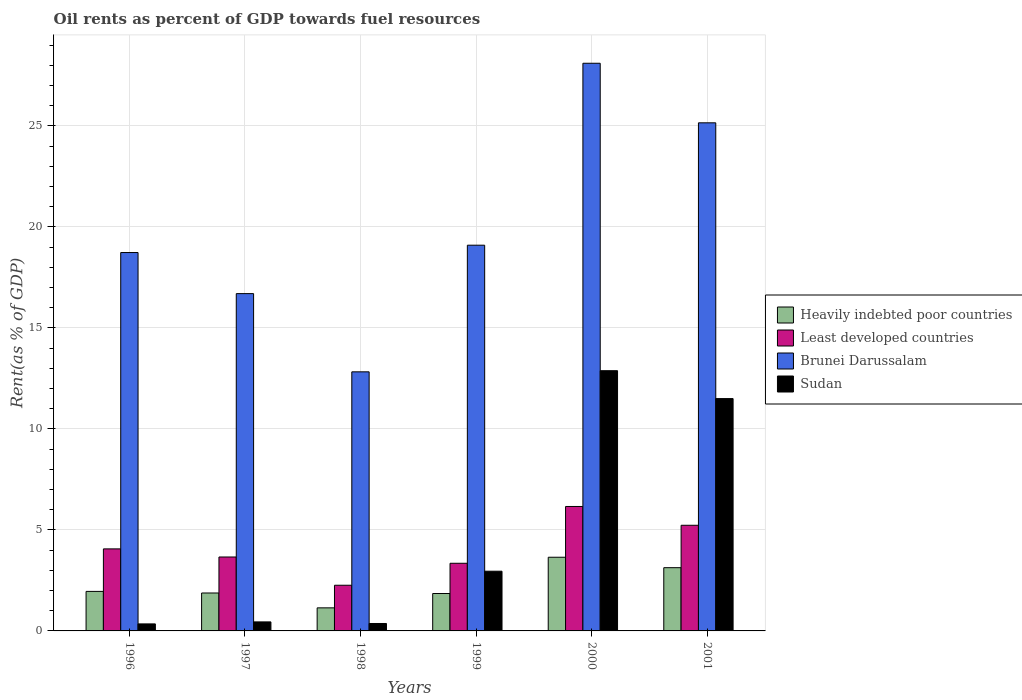How many different coloured bars are there?
Your answer should be very brief. 4. Are the number of bars on each tick of the X-axis equal?
Your response must be concise. Yes. How many bars are there on the 2nd tick from the right?
Make the answer very short. 4. What is the oil rent in Sudan in 1999?
Give a very brief answer. 2.96. Across all years, what is the maximum oil rent in Least developed countries?
Provide a short and direct response. 6.16. Across all years, what is the minimum oil rent in Least developed countries?
Offer a terse response. 2.26. In which year was the oil rent in Heavily indebted poor countries maximum?
Provide a succinct answer. 2000. In which year was the oil rent in Sudan minimum?
Provide a short and direct response. 1996. What is the total oil rent in Sudan in the graph?
Ensure brevity in your answer.  28.5. What is the difference between the oil rent in Least developed countries in 1998 and that in 2000?
Make the answer very short. -3.9. What is the difference between the oil rent in Brunei Darussalam in 2000 and the oil rent in Sudan in 1996?
Provide a succinct answer. 27.76. What is the average oil rent in Heavily indebted poor countries per year?
Give a very brief answer. 2.27. In the year 2001, what is the difference between the oil rent in Brunei Darussalam and oil rent in Heavily indebted poor countries?
Keep it short and to the point. 22.02. What is the ratio of the oil rent in Sudan in 1996 to that in 1998?
Make the answer very short. 0.94. Is the oil rent in Brunei Darussalam in 1998 less than that in 1999?
Provide a short and direct response. Yes. Is the difference between the oil rent in Brunei Darussalam in 1997 and 2000 greater than the difference between the oil rent in Heavily indebted poor countries in 1997 and 2000?
Your response must be concise. No. What is the difference between the highest and the second highest oil rent in Sudan?
Offer a terse response. 1.38. What is the difference between the highest and the lowest oil rent in Heavily indebted poor countries?
Your answer should be compact. 2.51. In how many years, is the oil rent in Heavily indebted poor countries greater than the average oil rent in Heavily indebted poor countries taken over all years?
Keep it short and to the point. 2. Is the sum of the oil rent in Brunei Darussalam in 1998 and 1999 greater than the maximum oil rent in Heavily indebted poor countries across all years?
Your response must be concise. Yes. Is it the case that in every year, the sum of the oil rent in Brunei Darussalam and oil rent in Least developed countries is greater than the sum of oil rent in Sudan and oil rent in Heavily indebted poor countries?
Your answer should be compact. Yes. What does the 3rd bar from the left in 2001 represents?
Ensure brevity in your answer.  Brunei Darussalam. What does the 2nd bar from the right in 2001 represents?
Ensure brevity in your answer.  Brunei Darussalam. Is it the case that in every year, the sum of the oil rent in Heavily indebted poor countries and oil rent in Sudan is greater than the oil rent in Brunei Darussalam?
Your answer should be compact. No. How many years are there in the graph?
Ensure brevity in your answer.  6. What is the difference between two consecutive major ticks on the Y-axis?
Provide a succinct answer. 5. Are the values on the major ticks of Y-axis written in scientific E-notation?
Your answer should be very brief. No. How many legend labels are there?
Your answer should be compact. 4. What is the title of the graph?
Provide a succinct answer. Oil rents as percent of GDP towards fuel resources. What is the label or title of the X-axis?
Your response must be concise. Years. What is the label or title of the Y-axis?
Ensure brevity in your answer.  Rent(as % of GDP). What is the Rent(as % of GDP) of Heavily indebted poor countries in 1996?
Offer a terse response. 1.96. What is the Rent(as % of GDP) of Least developed countries in 1996?
Provide a short and direct response. 4.06. What is the Rent(as % of GDP) in Brunei Darussalam in 1996?
Make the answer very short. 18.73. What is the Rent(as % of GDP) in Sudan in 1996?
Offer a terse response. 0.35. What is the Rent(as % of GDP) in Heavily indebted poor countries in 1997?
Your answer should be compact. 1.88. What is the Rent(as % of GDP) in Least developed countries in 1997?
Make the answer very short. 3.66. What is the Rent(as % of GDP) of Brunei Darussalam in 1997?
Provide a short and direct response. 16.7. What is the Rent(as % of GDP) of Sudan in 1997?
Keep it short and to the point. 0.45. What is the Rent(as % of GDP) of Heavily indebted poor countries in 1998?
Offer a very short reply. 1.14. What is the Rent(as % of GDP) in Least developed countries in 1998?
Your answer should be very brief. 2.26. What is the Rent(as % of GDP) in Brunei Darussalam in 1998?
Keep it short and to the point. 12.83. What is the Rent(as % of GDP) in Sudan in 1998?
Give a very brief answer. 0.37. What is the Rent(as % of GDP) in Heavily indebted poor countries in 1999?
Offer a terse response. 1.85. What is the Rent(as % of GDP) of Least developed countries in 1999?
Offer a very short reply. 3.35. What is the Rent(as % of GDP) in Brunei Darussalam in 1999?
Your response must be concise. 19.1. What is the Rent(as % of GDP) in Sudan in 1999?
Provide a short and direct response. 2.96. What is the Rent(as % of GDP) in Heavily indebted poor countries in 2000?
Ensure brevity in your answer.  3.65. What is the Rent(as % of GDP) in Least developed countries in 2000?
Make the answer very short. 6.16. What is the Rent(as % of GDP) in Brunei Darussalam in 2000?
Your response must be concise. 28.1. What is the Rent(as % of GDP) in Sudan in 2000?
Provide a succinct answer. 12.88. What is the Rent(as % of GDP) of Heavily indebted poor countries in 2001?
Your answer should be compact. 3.13. What is the Rent(as % of GDP) of Least developed countries in 2001?
Give a very brief answer. 5.23. What is the Rent(as % of GDP) in Brunei Darussalam in 2001?
Your answer should be compact. 25.15. What is the Rent(as % of GDP) in Sudan in 2001?
Your answer should be compact. 11.5. Across all years, what is the maximum Rent(as % of GDP) of Heavily indebted poor countries?
Provide a succinct answer. 3.65. Across all years, what is the maximum Rent(as % of GDP) of Least developed countries?
Your answer should be compact. 6.16. Across all years, what is the maximum Rent(as % of GDP) in Brunei Darussalam?
Ensure brevity in your answer.  28.1. Across all years, what is the maximum Rent(as % of GDP) in Sudan?
Provide a succinct answer. 12.88. Across all years, what is the minimum Rent(as % of GDP) in Heavily indebted poor countries?
Offer a terse response. 1.14. Across all years, what is the minimum Rent(as % of GDP) in Least developed countries?
Ensure brevity in your answer.  2.26. Across all years, what is the minimum Rent(as % of GDP) of Brunei Darussalam?
Your answer should be compact. 12.83. Across all years, what is the minimum Rent(as % of GDP) in Sudan?
Provide a short and direct response. 0.35. What is the total Rent(as % of GDP) of Heavily indebted poor countries in the graph?
Give a very brief answer. 13.61. What is the total Rent(as % of GDP) in Least developed countries in the graph?
Your answer should be very brief. 24.72. What is the total Rent(as % of GDP) of Brunei Darussalam in the graph?
Provide a short and direct response. 120.61. What is the total Rent(as % of GDP) in Sudan in the graph?
Your answer should be compact. 28.5. What is the difference between the Rent(as % of GDP) of Heavily indebted poor countries in 1996 and that in 1997?
Your answer should be compact. 0.08. What is the difference between the Rent(as % of GDP) in Least developed countries in 1996 and that in 1997?
Provide a short and direct response. 0.4. What is the difference between the Rent(as % of GDP) of Brunei Darussalam in 1996 and that in 1997?
Your answer should be compact. 2.03. What is the difference between the Rent(as % of GDP) in Sudan in 1996 and that in 1997?
Ensure brevity in your answer.  -0.1. What is the difference between the Rent(as % of GDP) of Heavily indebted poor countries in 1996 and that in 1998?
Your response must be concise. 0.81. What is the difference between the Rent(as % of GDP) of Least developed countries in 1996 and that in 1998?
Your answer should be very brief. 1.8. What is the difference between the Rent(as % of GDP) of Brunei Darussalam in 1996 and that in 1998?
Offer a terse response. 5.91. What is the difference between the Rent(as % of GDP) in Sudan in 1996 and that in 1998?
Your response must be concise. -0.02. What is the difference between the Rent(as % of GDP) in Heavily indebted poor countries in 1996 and that in 1999?
Provide a short and direct response. 0.1. What is the difference between the Rent(as % of GDP) in Least developed countries in 1996 and that in 1999?
Offer a terse response. 0.71. What is the difference between the Rent(as % of GDP) of Brunei Darussalam in 1996 and that in 1999?
Your answer should be very brief. -0.36. What is the difference between the Rent(as % of GDP) of Sudan in 1996 and that in 1999?
Your answer should be very brief. -2.61. What is the difference between the Rent(as % of GDP) of Heavily indebted poor countries in 1996 and that in 2000?
Your response must be concise. -1.69. What is the difference between the Rent(as % of GDP) in Least developed countries in 1996 and that in 2000?
Your answer should be compact. -2.1. What is the difference between the Rent(as % of GDP) in Brunei Darussalam in 1996 and that in 2000?
Your response must be concise. -9.37. What is the difference between the Rent(as % of GDP) of Sudan in 1996 and that in 2000?
Your response must be concise. -12.54. What is the difference between the Rent(as % of GDP) of Heavily indebted poor countries in 1996 and that in 2001?
Provide a succinct answer. -1.17. What is the difference between the Rent(as % of GDP) of Least developed countries in 1996 and that in 2001?
Ensure brevity in your answer.  -1.17. What is the difference between the Rent(as % of GDP) of Brunei Darussalam in 1996 and that in 2001?
Keep it short and to the point. -6.42. What is the difference between the Rent(as % of GDP) of Sudan in 1996 and that in 2001?
Provide a succinct answer. -11.15. What is the difference between the Rent(as % of GDP) of Heavily indebted poor countries in 1997 and that in 1998?
Give a very brief answer. 0.74. What is the difference between the Rent(as % of GDP) of Least developed countries in 1997 and that in 1998?
Your answer should be compact. 1.4. What is the difference between the Rent(as % of GDP) in Brunei Darussalam in 1997 and that in 1998?
Offer a very short reply. 3.87. What is the difference between the Rent(as % of GDP) of Sudan in 1997 and that in 1998?
Offer a terse response. 0.08. What is the difference between the Rent(as % of GDP) in Heavily indebted poor countries in 1997 and that in 1999?
Provide a short and direct response. 0.03. What is the difference between the Rent(as % of GDP) in Least developed countries in 1997 and that in 1999?
Ensure brevity in your answer.  0.31. What is the difference between the Rent(as % of GDP) of Brunei Darussalam in 1997 and that in 1999?
Your answer should be compact. -2.4. What is the difference between the Rent(as % of GDP) in Sudan in 1997 and that in 1999?
Provide a short and direct response. -2.51. What is the difference between the Rent(as % of GDP) of Heavily indebted poor countries in 1997 and that in 2000?
Your answer should be compact. -1.77. What is the difference between the Rent(as % of GDP) in Least developed countries in 1997 and that in 2000?
Ensure brevity in your answer.  -2.5. What is the difference between the Rent(as % of GDP) in Brunei Darussalam in 1997 and that in 2000?
Offer a terse response. -11.4. What is the difference between the Rent(as % of GDP) of Sudan in 1997 and that in 2000?
Make the answer very short. -12.44. What is the difference between the Rent(as % of GDP) of Heavily indebted poor countries in 1997 and that in 2001?
Provide a short and direct response. -1.25. What is the difference between the Rent(as % of GDP) of Least developed countries in 1997 and that in 2001?
Keep it short and to the point. -1.57. What is the difference between the Rent(as % of GDP) of Brunei Darussalam in 1997 and that in 2001?
Your answer should be very brief. -8.46. What is the difference between the Rent(as % of GDP) of Sudan in 1997 and that in 2001?
Your answer should be very brief. -11.06. What is the difference between the Rent(as % of GDP) of Heavily indebted poor countries in 1998 and that in 1999?
Offer a very short reply. -0.71. What is the difference between the Rent(as % of GDP) of Least developed countries in 1998 and that in 1999?
Make the answer very short. -1.09. What is the difference between the Rent(as % of GDP) of Brunei Darussalam in 1998 and that in 1999?
Your answer should be very brief. -6.27. What is the difference between the Rent(as % of GDP) of Sudan in 1998 and that in 1999?
Provide a succinct answer. -2.59. What is the difference between the Rent(as % of GDP) of Heavily indebted poor countries in 1998 and that in 2000?
Provide a succinct answer. -2.51. What is the difference between the Rent(as % of GDP) of Least developed countries in 1998 and that in 2000?
Your response must be concise. -3.9. What is the difference between the Rent(as % of GDP) of Brunei Darussalam in 1998 and that in 2000?
Provide a succinct answer. -15.28. What is the difference between the Rent(as % of GDP) of Sudan in 1998 and that in 2000?
Offer a very short reply. -12.52. What is the difference between the Rent(as % of GDP) of Heavily indebted poor countries in 1998 and that in 2001?
Your answer should be compact. -1.99. What is the difference between the Rent(as % of GDP) of Least developed countries in 1998 and that in 2001?
Your answer should be compact. -2.97. What is the difference between the Rent(as % of GDP) of Brunei Darussalam in 1998 and that in 2001?
Your response must be concise. -12.33. What is the difference between the Rent(as % of GDP) in Sudan in 1998 and that in 2001?
Your answer should be compact. -11.13. What is the difference between the Rent(as % of GDP) in Heavily indebted poor countries in 1999 and that in 2000?
Your answer should be compact. -1.8. What is the difference between the Rent(as % of GDP) of Least developed countries in 1999 and that in 2000?
Your answer should be compact. -2.81. What is the difference between the Rent(as % of GDP) in Brunei Darussalam in 1999 and that in 2000?
Keep it short and to the point. -9.01. What is the difference between the Rent(as % of GDP) in Sudan in 1999 and that in 2000?
Give a very brief answer. -9.93. What is the difference between the Rent(as % of GDP) of Heavily indebted poor countries in 1999 and that in 2001?
Offer a terse response. -1.28. What is the difference between the Rent(as % of GDP) of Least developed countries in 1999 and that in 2001?
Offer a very short reply. -1.88. What is the difference between the Rent(as % of GDP) of Brunei Darussalam in 1999 and that in 2001?
Provide a short and direct response. -6.06. What is the difference between the Rent(as % of GDP) of Sudan in 1999 and that in 2001?
Provide a short and direct response. -8.55. What is the difference between the Rent(as % of GDP) of Heavily indebted poor countries in 2000 and that in 2001?
Give a very brief answer. 0.52. What is the difference between the Rent(as % of GDP) of Least developed countries in 2000 and that in 2001?
Your answer should be compact. 0.93. What is the difference between the Rent(as % of GDP) in Brunei Darussalam in 2000 and that in 2001?
Provide a succinct answer. 2.95. What is the difference between the Rent(as % of GDP) in Sudan in 2000 and that in 2001?
Ensure brevity in your answer.  1.38. What is the difference between the Rent(as % of GDP) in Heavily indebted poor countries in 1996 and the Rent(as % of GDP) in Least developed countries in 1997?
Ensure brevity in your answer.  -1.7. What is the difference between the Rent(as % of GDP) in Heavily indebted poor countries in 1996 and the Rent(as % of GDP) in Brunei Darussalam in 1997?
Give a very brief answer. -14.74. What is the difference between the Rent(as % of GDP) in Heavily indebted poor countries in 1996 and the Rent(as % of GDP) in Sudan in 1997?
Offer a very short reply. 1.51. What is the difference between the Rent(as % of GDP) of Least developed countries in 1996 and the Rent(as % of GDP) of Brunei Darussalam in 1997?
Ensure brevity in your answer.  -12.64. What is the difference between the Rent(as % of GDP) in Least developed countries in 1996 and the Rent(as % of GDP) in Sudan in 1997?
Your answer should be compact. 3.62. What is the difference between the Rent(as % of GDP) in Brunei Darussalam in 1996 and the Rent(as % of GDP) in Sudan in 1997?
Make the answer very short. 18.29. What is the difference between the Rent(as % of GDP) in Heavily indebted poor countries in 1996 and the Rent(as % of GDP) in Least developed countries in 1998?
Offer a terse response. -0.3. What is the difference between the Rent(as % of GDP) in Heavily indebted poor countries in 1996 and the Rent(as % of GDP) in Brunei Darussalam in 1998?
Ensure brevity in your answer.  -10.87. What is the difference between the Rent(as % of GDP) of Heavily indebted poor countries in 1996 and the Rent(as % of GDP) of Sudan in 1998?
Your answer should be compact. 1.59. What is the difference between the Rent(as % of GDP) of Least developed countries in 1996 and the Rent(as % of GDP) of Brunei Darussalam in 1998?
Your response must be concise. -8.76. What is the difference between the Rent(as % of GDP) in Least developed countries in 1996 and the Rent(as % of GDP) in Sudan in 1998?
Offer a terse response. 3.69. What is the difference between the Rent(as % of GDP) of Brunei Darussalam in 1996 and the Rent(as % of GDP) of Sudan in 1998?
Give a very brief answer. 18.36. What is the difference between the Rent(as % of GDP) of Heavily indebted poor countries in 1996 and the Rent(as % of GDP) of Least developed countries in 1999?
Give a very brief answer. -1.39. What is the difference between the Rent(as % of GDP) of Heavily indebted poor countries in 1996 and the Rent(as % of GDP) of Brunei Darussalam in 1999?
Offer a very short reply. -17.14. What is the difference between the Rent(as % of GDP) in Heavily indebted poor countries in 1996 and the Rent(as % of GDP) in Sudan in 1999?
Your response must be concise. -1. What is the difference between the Rent(as % of GDP) in Least developed countries in 1996 and the Rent(as % of GDP) in Brunei Darussalam in 1999?
Keep it short and to the point. -15.03. What is the difference between the Rent(as % of GDP) in Least developed countries in 1996 and the Rent(as % of GDP) in Sudan in 1999?
Give a very brief answer. 1.11. What is the difference between the Rent(as % of GDP) in Brunei Darussalam in 1996 and the Rent(as % of GDP) in Sudan in 1999?
Your response must be concise. 15.78. What is the difference between the Rent(as % of GDP) of Heavily indebted poor countries in 1996 and the Rent(as % of GDP) of Least developed countries in 2000?
Offer a very short reply. -4.2. What is the difference between the Rent(as % of GDP) in Heavily indebted poor countries in 1996 and the Rent(as % of GDP) in Brunei Darussalam in 2000?
Give a very brief answer. -26.15. What is the difference between the Rent(as % of GDP) in Heavily indebted poor countries in 1996 and the Rent(as % of GDP) in Sudan in 2000?
Offer a terse response. -10.93. What is the difference between the Rent(as % of GDP) in Least developed countries in 1996 and the Rent(as % of GDP) in Brunei Darussalam in 2000?
Give a very brief answer. -24.04. What is the difference between the Rent(as % of GDP) in Least developed countries in 1996 and the Rent(as % of GDP) in Sudan in 2000?
Your answer should be very brief. -8.82. What is the difference between the Rent(as % of GDP) of Brunei Darussalam in 1996 and the Rent(as % of GDP) of Sudan in 2000?
Offer a terse response. 5.85. What is the difference between the Rent(as % of GDP) in Heavily indebted poor countries in 1996 and the Rent(as % of GDP) in Least developed countries in 2001?
Your response must be concise. -3.27. What is the difference between the Rent(as % of GDP) in Heavily indebted poor countries in 1996 and the Rent(as % of GDP) in Brunei Darussalam in 2001?
Your response must be concise. -23.2. What is the difference between the Rent(as % of GDP) in Heavily indebted poor countries in 1996 and the Rent(as % of GDP) in Sudan in 2001?
Your answer should be very brief. -9.55. What is the difference between the Rent(as % of GDP) in Least developed countries in 1996 and the Rent(as % of GDP) in Brunei Darussalam in 2001?
Give a very brief answer. -21.09. What is the difference between the Rent(as % of GDP) of Least developed countries in 1996 and the Rent(as % of GDP) of Sudan in 2001?
Ensure brevity in your answer.  -7.44. What is the difference between the Rent(as % of GDP) in Brunei Darussalam in 1996 and the Rent(as % of GDP) in Sudan in 2001?
Offer a terse response. 7.23. What is the difference between the Rent(as % of GDP) in Heavily indebted poor countries in 1997 and the Rent(as % of GDP) in Least developed countries in 1998?
Ensure brevity in your answer.  -0.38. What is the difference between the Rent(as % of GDP) of Heavily indebted poor countries in 1997 and the Rent(as % of GDP) of Brunei Darussalam in 1998?
Give a very brief answer. -10.95. What is the difference between the Rent(as % of GDP) in Heavily indebted poor countries in 1997 and the Rent(as % of GDP) in Sudan in 1998?
Keep it short and to the point. 1.51. What is the difference between the Rent(as % of GDP) in Least developed countries in 1997 and the Rent(as % of GDP) in Brunei Darussalam in 1998?
Provide a succinct answer. -9.17. What is the difference between the Rent(as % of GDP) in Least developed countries in 1997 and the Rent(as % of GDP) in Sudan in 1998?
Make the answer very short. 3.29. What is the difference between the Rent(as % of GDP) of Brunei Darussalam in 1997 and the Rent(as % of GDP) of Sudan in 1998?
Keep it short and to the point. 16.33. What is the difference between the Rent(as % of GDP) in Heavily indebted poor countries in 1997 and the Rent(as % of GDP) in Least developed countries in 1999?
Ensure brevity in your answer.  -1.47. What is the difference between the Rent(as % of GDP) of Heavily indebted poor countries in 1997 and the Rent(as % of GDP) of Brunei Darussalam in 1999?
Give a very brief answer. -17.22. What is the difference between the Rent(as % of GDP) in Heavily indebted poor countries in 1997 and the Rent(as % of GDP) in Sudan in 1999?
Ensure brevity in your answer.  -1.08. What is the difference between the Rent(as % of GDP) of Least developed countries in 1997 and the Rent(as % of GDP) of Brunei Darussalam in 1999?
Provide a short and direct response. -15.44. What is the difference between the Rent(as % of GDP) in Least developed countries in 1997 and the Rent(as % of GDP) in Sudan in 1999?
Provide a short and direct response. 0.7. What is the difference between the Rent(as % of GDP) in Brunei Darussalam in 1997 and the Rent(as % of GDP) in Sudan in 1999?
Provide a short and direct response. 13.74. What is the difference between the Rent(as % of GDP) in Heavily indebted poor countries in 1997 and the Rent(as % of GDP) in Least developed countries in 2000?
Your answer should be very brief. -4.28. What is the difference between the Rent(as % of GDP) of Heavily indebted poor countries in 1997 and the Rent(as % of GDP) of Brunei Darussalam in 2000?
Offer a very short reply. -26.23. What is the difference between the Rent(as % of GDP) in Heavily indebted poor countries in 1997 and the Rent(as % of GDP) in Sudan in 2000?
Keep it short and to the point. -11.01. What is the difference between the Rent(as % of GDP) in Least developed countries in 1997 and the Rent(as % of GDP) in Brunei Darussalam in 2000?
Give a very brief answer. -24.44. What is the difference between the Rent(as % of GDP) in Least developed countries in 1997 and the Rent(as % of GDP) in Sudan in 2000?
Your response must be concise. -9.22. What is the difference between the Rent(as % of GDP) of Brunei Darussalam in 1997 and the Rent(as % of GDP) of Sudan in 2000?
Your answer should be compact. 3.82. What is the difference between the Rent(as % of GDP) in Heavily indebted poor countries in 1997 and the Rent(as % of GDP) in Least developed countries in 2001?
Make the answer very short. -3.35. What is the difference between the Rent(as % of GDP) in Heavily indebted poor countries in 1997 and the Rent(as % of GDP) in Brunei Darussalam in 2001?
Keep it short and to the point. -23.28. What is the difference between the Rent(as % of GDP) of Heavily indebted poor countries in 1997 and the Rent(as % of GDP) of Sudan in 2001?
Keep it short and to the point. -9.62. What is the difference between the Rent(as % of GDP) of Least developed countries in 1997 and the Rent(as % of GDP) of Brunei Darussalam in 2001?
Give a very brief answer. -21.49. What is the difference between the Rent(as % of GDP) in Least developed countries in 1997 and the Rent(as % of GDP) in Sudan in 2001?
Keep it short and to the point. -7.84. What is the difference between the Rent(as % of GDP) in Brunei Darussalam in 1997 and the Rent(as % of GDP) in Sudan in 2001?
Provide a succinct answer. 5.2. What is the difference between the Rent(as % of GDP) in Heavily indebted poor countries in 1998 and the Rent(as % of GDP) in Least developed countries in 1999?
Offer a very short reply. -2.21. What is the difference between the Rent(as % of GDP) of Heavily indebted poor countries in 1998 and the Rent(as % of GDP) of Brunei Darussalam in 1999?
Your response must be concise. -17.95. What is the difference between the Rent(as % of GDP) of Heavily indebted poor countries in 1998 and the Rent(as % of GDP) of Sudan in 1999?
Your answer should be very brief. -1.81. What is the difference between the Rent(as % of GDP) of Least developed countries in 1998 and the Rent(as % of GDP) of Brunei Darussalam in 1999?
Your response must be concise. -16.83. What is the difference between the Rent(as % of GDP) of Least developed countries in 1998 and the Rent(as % of GDP) of Sudan in 1999?
Offer a very short reply. -0.69. What is the difference between the Rent(as % of GDP) of Brunei Darussalam in 1998 and the Rent(as % of GDP) of Sudan in 1999?
Your answer should be very brief. 9.87. What is the difference between the Rent(as % of GDP) of Heavily indebted poor countries in 1998 and the Rent(as % of GDP) of Least developed countries in 2000?
Your answer should be compact. -5.02. What is the difference between the Rent(as % of GDP) of Heavily indebted poor countries in 1998 and the Rent(as % of GDP) of Brunei Darussalam in 2000?
Offer a terse response. -26.96. What is the difference between the Rent(as % of GDP) in Heavily indebted poor countries in 1998 and the Rent(as % of GDP) in Sudan in 2000?
Ensure brevity in your answer.  -11.74. What is the difference between the Rent(as % of GDP) in Least developed countries in 1998 and the Rent(as % of GDP) in Brunei Darussalam in 2000?
Your answer should be very brief. -25.84. What is the difference between the Rent(as % of GDP) of Least developed countries in 1998 and the Rent(as % of GDP) of Sudan in 2000?
Your response must be concise. -10.62. What is the difference between the Rent(as % of GDP) in Brunei Darussalam in 1998 and the Rent(as % of GDP) in Sudan in 2000?
Ensure brevity in your answer.  -0.06. What is the difference between the Rent(as % of GDP) of Heavily indebted poor countries in 1998 and the Rent(as % of GDP) of Least developed countries in 2001?
Provide a short and direct response. -4.09. What is the difference between the Rent(as % of GDP) of Heavily indebted poor countries in 1998 and the Rent(as % of GDP) of Brunei Darussalam in 2001?
Ensure brevity in your answer.  -24.01. What is the difference between the Rent(as % of GDP) in Heavily indebted poor countries in 1998 and the Rent(as % of GDP) in Sudan in 2001?
Give a very brief answer. -10.36. What is the difference between the Rent(as % of GDP) in Least developed countries in 1998 and the Rent(as % of GDP) in Brunei Darussalam in 2001?
Offer a very short reply. -22.89. What is the difference between the Rent(as % of GDP) of Least developed countries in 1998 and the Rent(as % of GDP) of Sudan in 2001?
Keep it short and to the point. -9.24. What is the difference between the Rent(as % of GDP) in Brunei Darussalam in 1998 and the Rent(as % of GDP) in Sudan in 2001?
Provide a short and direct response. 1.32. What is the difference between the Rent(as % of GDP) in Heavily indebted poor countries in 1999 and the Rent(as % of GDP) in Least developed countries in 2000?
Offer a terse response. -4.31. What is the difference between the Rent(as % of GDP) of Heavily indebted poor countries in 1999 and the Rent(as % of GDP) of Brunei Darussalam in 2000?
Keep it short and to the point. -26.25. What is the difference between the Rent(as % of GDP) in Heavily indebted poor countries in 1999 and the Rent(as % of GDP) in Sudan in 2000?
Offer a terse response. -11.03. What is the difference between the Rent(as % of GDP) of Least developed countries in 1999 and the Rent(as % of GDP) of Brunei Darussalam in 2000?
Your answer should be very brief. -24.75. What is the difference between the Rent(as % of GDP) in Least developed countries in 1999 and the Rent(as % of GDP) in Sudan in 2000?
Provide a succinct answer. -9.53. What is the difference between the Rent(as % of GDP) of Brunei Darussalam in 1999 and the Rent(as % of GDP) of Sudan in 2000?
Make the answer very short. 6.21. What is the difference between the Rent(as % of GDP) in Heavily indebted poor countries in 1999 and the Rent(as % of GDP) in Least developed countries in 2001?
Make the answer very short. -3.38. What is the difference between the Rent(as % of GDP) of Heavily indebted poor countries in 1999 and the Rent(as % of GDP) of Brunei Darussalam in 2001?
Provide a succinct answer. -23.3. What is the difference between the Rent(as % of GDP) of Heavily indebted poor countries in 1999 and the Rent(as % of GDP) of Sudan in 2001?
Give a very brief answer. -9.65. What is the difference between the Rent(as % of GDP) in Least developed countries in 1999 and the Rent(as % of GDP) in Brunei Darussalam in 2001?
Keep it short and to the point. -21.81. What is the difference between the Rent(as % of GDP) of Least developed countries in 1999 and the Rent(as % of GDP) of Sudan in 2001?
Your response must be concise. -8.15. What is the difference between the Rent(as % of GDP) of Brunei Darussalam in 1999 and the Rent(as % of GDP) of Sudan in 2001?
Ensure brevity in your answer.  7.59. What is the difference between the Rent(as % of GDP) of Heavily indebted poor countries in 2000 and the Rent(as % of GDP) of Least developed countries in 2001?
Your response must be concise. -1.58. What is the difference between the Rent(as % of GDP) in Heavily indebted poor countries in 2000 and the Rent(as % of GDP) in Brunei Darussalam in 2001?
Give a very brief answer. -21.51. What is the difference between the Rent(as % of GDP) of Heavily indebted poor countries in 2000 and the Rent(as % of GDP) of Sudan in 2001?
Your response must be concise. -7.85. What is the difference between the Rent(as % of GDP) of Least developed countries in 2000 and the Rent(as % of GDP) of Brunei Darussalam in 2001?
Your answer should be very brief. -18.99. What is the difference between the Rent(as % of GDP) of Least developed countries in 2000 and the Rent(as % of GDP) of Sudan in 2001?
Your answer should be very brief. -5.34. What is the difference between the Rent(as % of GDP) of Brunei Darussalam in 2000 and the Rent(as % of GDP) of Sudan in 2001?
Your answer should be compact. 16.6. What is the average Rent(as % of GDP) of Heavily indebted poor countries per year?
Provide a short and direct response. 2.27. What is the average Rent(as % of GDP) of Least developed countries per year?
Provide a succinct answer. 4.12. What is the average Rent(as % of GDP) of Brunei Darussalam per year?
Provide a succinct answer. 20.1. What is the average Rent(as % of GDP) of Sudan per year?
Give a very brief answer. 4.75. In the year 1996, what is the difference between the Rent(as % of GDP) of Heavily indebted poor countries and Rent(as % of GDP) of Least developed countries?
Ensure brevity in your answer.  -2.1. In the year 1996, what is the difference between the Rent(as % of GDP) in Heavily indebted poor countries and Rent(as % of GDP) in Brunei Darussalam?
Your answer should be very brief. -16.78. In the year 1996, what is the difference between the Rent(as % of GDP) of Heavily indebted poor countries and Rent(as % of GDP) of Sudan?
Keep it short and to the point. 1.61. In the year 1996, what is the difference between the Rent(as % of GDP) in Least developed countries and Rent(as % of GDP) in Brunei Darussalam?
Keep it short and to the point. -14.67. In the year 1996, what is the difference between the Rent(as % of GDP) of Least developed countries and Rent(as % of GDP) of Sudan?
Offer a terse response. 3.71. In the year 1996, what is the difference between the Rent(as % of GDP) in Brunei Darussalam and Rent(as % of GDP) in Sudan?
Give a very brief answer. 18.39. In the year 1997, what is the difference between the Rent(as % of GDP) in Heavily indebted poor countries and Rent(as % of GDP) in Least developed countries?
Your answer should be very brief. -1.78. In the year 1997, what is the difference between the Rent(as % of GDP) of Heavily indebted poor countries and Rent(as % of GDP) of Brunei Darussalam?
Your answer should be very brief. -14.82. In the year 1997, what is the difference between the Rent(as % of GDP) of Heavily indebted poor countries and Rent(as % of GDP) of Sudan?
Your response must be concise. 1.43. In the year 1997, what is the difference between the Rent(as % of GDP) of Least developed countries and Rent(as % of GDP) of Brunei Darussalam?
Offer a very short reply. -13.04. In the year 1997, what is the difference between the Rent(as % of GDP) of Least developed countries and Rent(as % of GDP) of Sudan?
Provide a short and direct response. 3.21. In the year 1997, what is the difference between the Rent(as % of GDP) of Brunei Darussalam and Rent(as % of GDP) of Sudan?
Keep it short and to the point. 16.25. In the year 1998, what is the difference between the Rent(as % of GDP) in Heavily indebted poor countries and Rent(as % of GDP) in Least developed countries?
Provide a short and direct response. -1.12. In the year 1998, what is the difference between the Rent(as % of GDP) of Heavily indebted poor countries and Rent(as % of GDP) of Brunei Darussalam?
Your answer should be compact. -11.68. In the year 1998, what is the difference between the Rent(as % of GDP) in Heavily indebted poor countries and Rent(as % of GDP) in Sudan?
Give a very brief answer. 0.77. In the year 1998, what is the difference between the Rent(as % of GDP) in Least developed countries and Rent(as % of GDP) in Brunei Darussalam?
Make the answer very short. -10.56. In the year 1998, what is the difference between the Rent(as % of GDP) in Least developed countries and Rent(as % of GDP) in Sudan?
Offer a terse response. 1.89. In the year 1998, what is the difference between the Rent(as % of GDP) in Brunei Darussalam and Rent(as % of GDP) in Sudan?
Your answer should be compact. 12.46. In the year 1999, what is the difference between the Rent(as % of GDP) of Heavily indebted poor countries and Rent(as % of GDP) of Least developed countries?
Provide a short and direct response. -1.5. In the year 1999, what is the difference between the Rent(as % of GDP) of Heavily indebted poor countries and Rent(as % of GDP) of Brunei Darussalam?
Provide a short and direct response. -17.24. In the year 1999, what is the difference between the Rent(as % of GDP) of Heavily indebted poor countries and Rent(as % of GDP) of Sudan?
Offer a terse response. -1.1. In the year 1999, what is the difference between the Rent(as % of GDP) of Least developed countries and Rent(as % of GDP) of Brunei Darussalam?
Offer a terse response. -15.75. In the year 1999, what is the difference between the Rent(as % of GDP) of Least developed countries and Rent(as % of GDP) of Sudan?
Your answer should be very brief. 0.39. In the year 1999, what is the difference between the Rent(as % of GDP) in Brunei Darussalam and Rent(as % of GDP) in Sudan?
Your response must be concise. 16.14. In the year 2000, what is the difference between the Rent(as % of GDP) in Heavily indebted poor countries and Rent(as % of GDP) in Least developed countries?
Your answer should be compact. -2.51. In the year 2000, what is the difference between the Rent(as % of GDP) in Heavily indebted poor countries and Rent(as % of GDP) in Brunei Darussalam?
Your response must be concise. -24.46. In the year 2000, what is the difference between the Rent(as % of GDP) in Heavily indebted poor countries and Rent(as % of GDP) in Sudan?
Provide a short and direct response. -9.23. In the year 2000, what is the difference between the Rent(as % of GDP) in Least developed countries and Rent(as % of GDP) in Brunei Darussalam?
Keep it short and to the point. -21.94. In the year 2000, what is the difference between the Rent(as % of GDP) in Least developed countries and Rent(as % of GDP) in Sudan?
Your answer should be very brief. -6.72. In the year 2000, what is the difference between the Rent(as % of GDP) in Brunei Darussalam and Rent(as % of GDP) in Sudan?
Your answer should be compact. 15.22. In the year 2001, what is the difference between the Rent(as % of GDP) of Heavily indebted poor countries and Rent(as % of GDP) of Least developed countries?
Make the answer very short. -2.1. In the year 2001, what is the difference between the Rent(as % of GDP) in Heavily indebted poor countries and Rent(as % of GDP) in Brunei Darussalam?
Your answer should be compact. -22.02. In the year 2001, what is the difference between the Rent(as % of GDP) of Heavily indebted poor countries and Rent(as % of GDP) of Sudan?
Your answer should be very brief. -8.37. In the year 2001, what is the difference between the Rent(as % of GDP) in Least developed countries and Rent(as % of GDP) in Brunei Darussalam?
Your answer should be very brief. -19.92. In the year 2001, what is the difference between the Rent(as % of GDP) in Least developed countries and Rent(as % of GDP) in Sudan?
Provide a succinct answer. -6.27. In the year 2001, what is the difference between the Rent(as % of GDP) in Brunei Darussalam and Rent(as % of GDP) in Sudan?
Offer a terse response. 13.65. What is the ratio of the Rent(as % of GDP) in Heavily indebted poor countries in 1996 to that in 1997?
Offer a very short reply. 1.04. What is the ratio of the Rent(as % of GDP) of Least developed countries in 1996 to that in 1997?
Your answer should be compact. 1.11. What is the ratio of the Rent(as % of GDP) of Brunei Darussalam in 1996 to that in 1997?
Provide a short and direct response. 1.12. What is the ratio of the Rent(as % of GDP) of Sudan in 1996 to that in 1997?
Provide a succinct answer. 0.78. What is the ratio of the Rent(as % of GDP) in Heavily indebted poor countries in 1996 to that in 1998?
Provide a succinct answer. 1.71. What is the ratio of the Rent(as % of GDP) in Least developed countries in 1996 to that in 1998?
Your response must be concise. 1.8. What is the ratio of the Rent(as % of GDP) of Brunei Darussalam in 1996 to that in 1998?
Provide a succinct answer. 1.46. What is the ratio of the Rent(as % of GDP) of Sudan in 1996 to that in 1998?
Ensure brevity in your answer.  0.94. What is the ratio of the Rent(as % of GDP) of Heavily indebted poor countries in 1996 to that in 1999?
Offer a terse response. 1.06. What is the ratio of the Rent(as % of GDP) in Least developed countries in 1996 to that in 1999?
Offer a very short reply. 1.21. What is the ratio of the Rent(as % of GDP) of Brunei Darussalam in 1996 to that in 1999?
Your answer should be compact. 0.98. What is the ratio of the Rent(as % of GDP) of Sudan in 1996 to that in 1999?
Your answer should be very brief. 0.12. What is the ratio of the Rent(as % of GDP) in Heavily indebted poor countries in 1996 to that in 2000?
Provide a short and direct response. 0.54. What is the ratio of the Rent(as % of GDP) in Least developed countries in 1996 to that in 2000?
Make the answer very short. 0.66. What is the ratio of the Rent(as % of GDP) of Brunei Darussalam in 1996 to that in 2000?
Make the answer very short. 0.67. What is the ratio of the Rent(as % of GDP) of Sudan in 1996 to that in 2000?
Offer a very short reply. 0.03. What is the ratio of the Rent(as % of GDP) of Heavily indebted poor countries in 1996 to that in 2001?
Offer a terse response. 0.63. What is the ratio of the Rent(as % of GDP) in Least developed countries in 1996 to that in 2001?
Provide a short and direct response. 0.78. What is the ratio of the Rent(as % of GDP) of Brunei Darussalam in 1996 to that in 2001?
Your response must be concise. 0.74. What is the ratio of the Rent(as % of GDP) in Sudan in 1996 to that in 2001?
Keep it short and to the point. 0.03. What is the ratio of the Rent(as % of GDP) of Heavily indebted poor countries in 1997 to that in 1998?
Provide a succinct answer. 1.64. What is the ratio of the Rent(as % of GDP) of Least developed countries in 1997 to that in 1998?
Make the answer very short. 1.62. What is the ratio of the Rent(as % of GDP) of Brunei Darussalam in 1997 to that in 1998?
Keep it short and to the point. 1.3. What is the ratio of the Rent(as % of GDP) in Sudan in 1997 to that in 1998?
Make the answer very short. 1.21. What is the ratio of the Rent(as % of GDP) of Heavily indebted poor countries in 1997 to that in 1999?
Provide a short and direct response. 1.01. What is the ratio of the Rent(as % of GDP) in Least developed countries in 1997 to that in 1999?
Keep it short and to the point. 1.09. What is the ratio of the Rent(as % of GDP) of Brunei Darussalam in 1997 to that in 1999?
Provide a short and direct response. 0.87. What is the ratio of the Rent(as % of GDP) of Sudan in 1997 to that in 1999?
Offer a terse response. 0.15. What is the ratio of the Rent(as % of GDP) in Heavily indebted poor countries in 1997 to that in 2000?
Provide a succinct answer. 0.51. What is the ratio of the Rent(as % of GDP) of Least developed countries in 1997 to that in 2000?
Offer a very short reply. 0.59. What is the ratio of the Rent(as % of GDP) of Brunei Darussalam in 1997 to that in 2000?
Provide a short and direct response. 0.59. What is the ratio of the Rent(as % of GDP) in Sudan in 1997 to that in 2000?
Your response must be concise. 0.03. What is the ratio of the Rent(as % of GDP) of Heavily indebted poor countries in 1997 to that in 2001?
Offer a terse response. 0.6. What is the ratio of the Rent(as % of GDP) of Least developed countries in 1997 to that in 2001?
Offer a terse response. 0.7. What is the ratio of the Rent(as % of GDP) of Brunei Darussalam in 1997 to that in 2001?
Offer a terse response. 0.66. What is the ratio of the Rent(as % of GDP) in Sudan in 1997 to that in 2001?
Ensure brevity in your answer.  0.04. What is the ratio of the Rent(as % of GDP) in Heavily indebted poor countries in 1998 to that in 1999?
Provide a succinct answer. 0.62. What is the ratio of the Rent(as % of GDP) in Least developed countries in 1998 to that in 1999?
Your answer should be very brief. 0.68. What is the ratio of the Rent(as % of GDP) in Brunei Darussalam in 1998 to that in 1999?
Keep it short and to the point. 0.67. What is the ratio of the Rent(as % of GDP) of Sudan in 1998 to that in 1999?
Your answer should be very brief. 0.12. What is the ratio of the Rent(as % of GDP) in Heavily indebted poor countries in 1998 to that in 2000?
Your answer should be very brief. 0.31. What is the ratio of the Rent(as % of GDP) in Least developed countries in 1998 to that in 2000?
Offer a very short reply. 0.37. What is the ratio of the Rent(as % of GDP) of Brunei Darussalam in 1998 to that in 2000?
Offer a very short reply. 0.46. What is the ratio of the Rent(as % of GDP) of Sudan in 1998 to that in 2000?
Provide a succinct answer. 0.03. What is the ratio of the Rent(as % of GDP) in Heavily indebted poor countries in 1998 to that in 2001?
Your answer should be compact. 0.36. What is the ratio of the Rent(as % of GDP) in Least developed countries in 1998 to that in 2001?
Ensure brevity in your answer.  0.43. What is the ratio of the Rent(as % of GDP) of Brunei Darussalam in 1998 to that in 2001?
Make the answer very short. 0.51. What is the ratio of the Rent(as % of GDP) of Sudan in 1998 to that in 2001?
Your answer should be very brief. 0.03. What is the ratio of the Rent(as % of GDP) of Heavily indebted poor countries in 1999 to that in 2000?
Offer a very short reply. 0.51. What is the ratio of the Rent(as % of GDP) in Least developed countries in 1999 to that in 2000?
Your answer should be very brief. 0.54. What is the ratio of the Rent(as % of GDP) in Brunei Darussalam in 1999 to that in 2000?
Your answer should be compact. 0.68. What is the ratio of the Rent(as % of GDP) in Sudan in 1999 to that in 2000?
Make the answer very short. 0.23. What is the ratio of the Rent(as % of GDP) of Heavily indebted poor countries in 1999 to that in 2001?
Your answer should be very brief. 0.59. What is the ratio of the Rent(as % of GDP) in Least developed countries in 1999 to that in 2001?
Your answer should be very brief. 0.64. What is the ratio of the Rent(as % of GDP) of Brunei Darussalam in 1999 to that in 2001?
Give a very brief answer. 0.76. What is the ratio of the Rent(as % of GDP) of Sudan in 1999 to that in 2001?
Your answer should be very brief. 0.26. What is the ratio of the Rent(as % of GDP) of Heavily indebted poor countries in 2000 to that in 2001?
Keep it short and to the point. 1.17. What is the ratio of the Rent(as % of GDP) in Least developed countries in 2000 to that in 2001?
Your response must be concise. 1.18. What is the ratio of the Rent(as % of GDP) in Brunei Darussalam in 2000 to that in 2001?
Ensure brevity in your answer.  1.12. What is the ratio of the Rent(as % of GDP) of Sudan in 2000 to that in 2001?
Provide a succinct answer. 1.12. What is the difference between the highest and the second highest Rent(as % of GDP) of Heavily indebted poor countries?
Make the answer very short. 0.52. What is the difference between the highest and the second highest Rent(as % of GDP) of Least developed countries?
Make the answer very short. 0.93. What is the difference between the highest and the second highest Rent(as % of GDP) of Brunei Darussalam?
Give a very brief answer. 2.95. What is the difference between the highest and the second highest Rent(as % of GDP) in Sudan?
Give a very brief answer. 1.38. What is the difference between the highest and the lowest Rent(as % of GDP) of Heavily indebted poor countries?
Your answer should be very brief. 2.51. What is the difference between the highest and the lowest Rent(as % of GDP) of Least developed countries?
Give a very brief answer. 3.9. What is the difference between the highest and the lowest Rent(as % of GDP) of Brunei Darussalam?
Keep it short and to the point. 15.28. What is the difference between the highest and the lowest Rent(as % of GDP) in Sudan?
Provide a short and direct response. 12.54. 